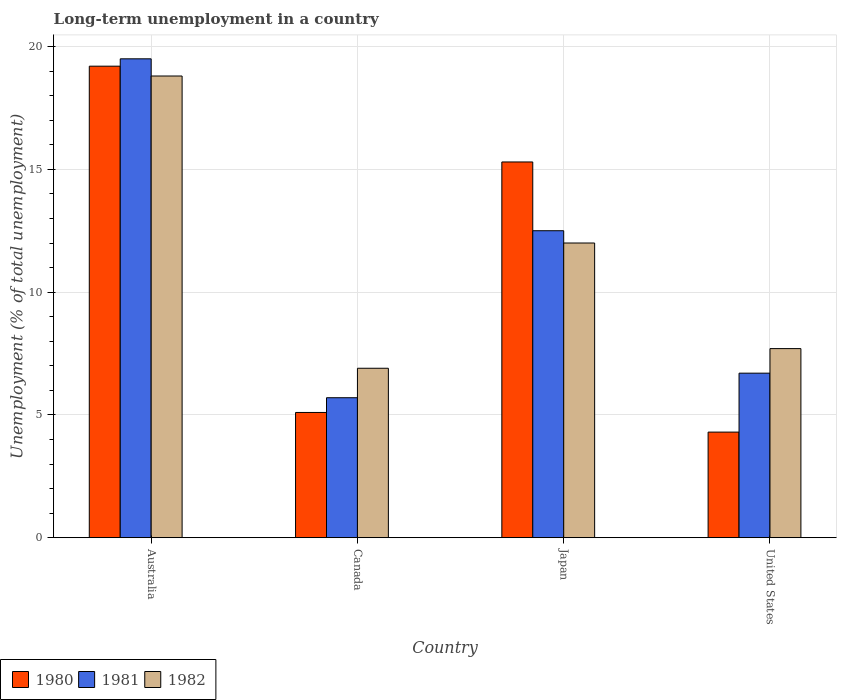How many different coloured bars are there?
Make the answer very short. 3. Are the number of bars per tick equal to the number of legend labels?
Provide a short and direct response. Yes. Are the number of bars on each tick of the X-axis equal?
Your answer should be very brief. Yes. How many bars are there on the 1st tick from the left?
Make the answer very short. 3. What is the percentage of long-term unemployed population in 1982 in United States?
Your response must be concise. 7.7. Across all countries, what is the maximum percentage of long-term unemployed population in 1982?
Your response must be concise. 18.8. Across all countries, what is the minimum percentage of long-term unemployed population in 1982?
Provide a short and direct response. 6.9. In which country was the percentage of long-term unemployed population in 1980 maximum?
Offer a terse response. Australia. What is the total percentage of long-term unemployed population in 1981 in the graph?
Provide a short and direct response. 44.4. What is the difference between the percentage of long-term unemployed population in 1981 in Australia and that in United States?
Ensure brevity in your answer.  12.8. What is the difference between the percentage of long-term unemployed population in 1980 in United States and the percentage of long-term unemployed population in 1981 in Japan?
Ensure brevity in your answer.  -8.2. What is the average percentage of long-term unemployed population in 1981 per country?
Give a very brief answer. 11.1. What is the difference between the percentage of long-term unemployed population of/in 1980 and percentage of long-term unemployed population of/in 1982 in Japan?
Offer a terse response. 3.3. In how many countries, is the percentage of long-term unemployed population in 1982 greater than 4 %?
Your answer should be compact. 4. What is the ratio of the percentage of long-term unemployed population in 1982 in Canada to that in Japan?
Provide a succinct answer. 0.58. Is the difference between the percentage of long-term unemployed population in 1980 in Australia and Canada greater than the difference between the percentage of long-term unemployed population in 1982 in Australia and Canada?
Offer a very short reply. Yes. What is the difference between the highest and the second highest percentage of long-term unemployed population in 1980?
Offer a very short reply. 14.1. What is the difference between the highest and the lowest percentage of long-term unemployed population in 1981?
Your response must be concise. 13.8. In how many countries, is the percentage of long-term unemployed population in 1980 greater than the average percentage of long-term unemployed population in 1980 taken over all countries?
Ensure brevity in your answer.  2. What does the 1st bar from the left in Japan represents?
Make the answer very short. 1980. Are all the bars in the graph horizontal?
Make the answer very short. No. How many legend labels are there?
Give a very brief answer. 3. How are the legend labels stacked?
Your response must be concise. Horizontal. What is the title of the graph?
Make the answer very short. Long-term unemployment in a country. What is the label or title of the Y-axis?
Your answer should be compact. Unemployment (% of total unemployment). What is the Unemployment (% of total unemployment) of 1980 in Australia?
Offer a terse response. 19.2. What is the Unemployment (% of total unemployment) of 1981 in Australia?
Make the answer very short. 19.5. What is the Unemployment (% of total unemployment) in 1982 in Australia?
Ensure brevity in your answer.  18.8. What is the Unemployment (% of total unemployment) of 1980 in Canada?
Your answer should be very brief. 5.1. What is the Unemployment (% of total unemployment) of 1981 in Canada?
Offer a terse response. 5.7. What is the Unemployment (% of total unemployment) of 1982 in Canada?
Ensure brevity in your answer.  6.9. What is the Unemployment (% of total unemployment) in 1980 in Japan?
Offer a very short reply. 15.3. What is the Unemployment (% of total unemployment) in 1981 in Japan?
Your answer should be very brief. 12.5. What is the Unemployment (% of total unemployment) of 1982 in Japan?
Offer a terse response. 12. What is the Unemployment (% of total unemployment) in 1980 in United States?
Provide a short and direct response. 4.3. What is the Unemployment (% of total unemployment) of 1981 in United States?
Your response must be concise. 6.7. What is the Unemployment (% of total unemployment) in 1982 in United States?
Make the answer very short. 7.7. Across all countries, what is the maximum Unemployment (% of total unemployment) in 1980?
Make the answer very short. 19.2. Across all countries, what is the maximum Unemployment (% of total unemployment) in 1982?
Make the answer very short. 18.8. Across all countries, what is the minimum Unemployment (% of total unemployment) in 1980?
Offer a very short reply. 4.3. Across all countries, what is the minimum Unemployment (% of total unemployment) in 1981?
Offer a terse response. 5.7. Across all countries, what is the minimum Unemployment (% of total unemployment) in 1982?
Your response must be concise. 6.9. What is the total Unemployment (% of total unemployment) of 1980 in the graph?
Offer a very short reply. 43.9. What is the total Unemployment (% of total unemployment) of 1981 in the graph?
Provide a short and direct response. 44.4. What is the total Unemployment (% of total unemployment) in 1982 in the graph?
Your answer should be compact. 45.4. What is the difference between the Unemployment (% of total unemployment) of 1982 in Australia and that in Canada?
Give a very brief answer. 11.9. What is the difference between the Unemployment (% of total unemployment) of 1982 in Australia and that in Japan?
Your response must be concise. 6.8. What is the difference between the Unemployment (% of total unemployment) of 1980 in Australia and that in United States?
Offer a terse response. 14.9. What is the difference between the Unemployment (% of total unemployment) of 1981 in Australia and that in United States?
Offer a very short reply. 12.8. What is the difference between the Unemployment (% of total unemployment) in 1982 in Australia and that in United States?
Provide a succinct answer. 11.1. What is the difference between the Unemployment (% of total unemployment) of 1981 in Canada and that in Japan?
Provide a short and direct response. -6.8. What is the difference between the Unemployment (% of total unemployment) in 1982 in Canada and that in Japan?
Give a very brief answer. -5.1. What is the difference between the Unemployment (% of total unemployment) in 1980 in Canada and that in United States?
Offer a terse response. 0.8. What is the difference between the Unemployment (% of total unemployment) in 1981 in Canada and that in United States?
Make the answer very short. -1. What is the difference between the Unemployment (% of total unemployment) of 1981 in Japan and that in United States?
Ensure brevity in your answer.  5.8. What is the difference between the Unemployment (% of total unemployment) in 1982 in Japan and that in United States?
Make the answer very short. 4.3. What is the difference between the Unemployment (% of total unemployment) in 1980 in Australia and the Unemployment (% of total unemployment) in 1982 in Canada?
Give a very brief answer. 12.3. What is the difference between the Unemployment (% of total unemployment) in 1980 in Australia and the Unemployment (% of total unemployment) in 1981 in Japan?
Offer a very short reply. 6.7. What is the difference between the Unemployment (% of total unemployment) in 1980 in Australia and the Unemployment (% of total unemployment) in 1981 in United States?
Keep it short and to the point. 12.5. What is the difference between the Unemployment (% of total unemployment) in 1980 in Australia and the Unemployment (% of total unemployment) in 1982 in United States?
Offer a terse response. 11.5. What is the difference between the Unemployment (% of total unemployment) in 1981 in Australia and the Unemployment (% of total unemployment) in 1982 in United States?
Give a very brief answer. 11.8. What is the difference between the Unemployment (% of total unemployment) of 1980 in Canada and the Unemployment (% of total unemployment) of 1982 in Japan?
Provide a short and direct response. -6.9. What is the difference between the Unemployment (% of total unemployment) of 1981 in Canada and the Unemployment (% of total unemployment) of 1982 in Japan?
Offer a terse response. -6.3. What is the difference between the Unemployment (% of total unemployment) of 1981 in Canada and the Unemployment (% of total unemployment) of 1982 in United States?
Your answer should be compact. -2. What is the difference between the Unemployment (% of total unemployment) in 1980 in Japan and the Unemployment (% of total unemployment) in 1982 in United States?
Give a very brief answer. 7.6. What is the difference between the Unemployment (% of total unemployment) of 1981 in Japan and the Unemployment (% of total unemployment) of 1982 in United States?
Provide a succinct answer. 4.8. What is the average Unemployment (% of total unemployment) in 1980 per country?
Make the answer very short. 10.97. What is the average Unemployment (% of total unemployment) of 1982 per country?
Make the answer very short. 11.35. What is the difference between the Unemployment (% of total unemployment) in 1980 and Unemployment (% of total unemployment) in 1982 in Australia?
Your answer should be compact. 0.4. What is the difference between the Unemployment (% of total unemployment) of 1981 and Unemployment (% of total unemployment) of 1982 in Australia?
Your response must be concise. 0.7. What is the difference between the Unemployment (% of total unemployment) of 1981 and Unemployment (% of total unemployment) of 1982 in Canada?
Ensure brevity in your answer.  -1.2. What is the difference between the Unemployment (% of total unemployment) of 1980 and Unemployment (% of total unemployment) of 1981 in Japan?
Your answer should be very brief. 2.8. What is the difference between the Unemployment (% of total unemployment) in 1981 and Unemployment (% of total unemployment) in 1982 in Japan?
Offer a very short reply. 0.5. What is the difference between the Unemployment (% of total unemployment) of 1980 and Unemployment (% of total unemployment) of 1981 in United States?
Make the answer very short. -2.4. What is the ratio of the Unemployment (% of total unemployment) in 1980 in Australia to that in Canada?
Your response must be concise. 3.76. What is the ratio of the Unemployment (% of total unemployment) of 1981 in Australia to that in Canada?
Ensure brevity in your answer.  3.42. What is the ratio of the Unemployment (% of total unemployment) in 1982 in Australia to that in Canada?
Your response must be concise. 2.72. What is the ratio of the Unemployment (% of total unemployment) of 1980 in Australia to that in Japan?
Ensure brevity in your answer.  1.25. What is the ratio of the Unemployment (% of total unemployment) in 1981 in Australia to that in Japan?
Your response must be concise. 1.56. What is the ratio of the Unemployment (% of total unemployment) of 1982 in Australia to that in Japan?
Your answer should be compact. 1.57. What is the ratio of the Unemployment (% of total unemployment) of 1980 in Australia to that in United States?
Provide a short and direct response. 4.47. What is the ratio of the Unemployment (% of total unemployment) of 1981 in Australia to that in United States?
Provide a succinct answer. 2.91. What is the ratio of the Unemployment (% of total unemployment) of 1982 in Australia to that in United States?
Your answer should be very brief. 2.44. What is the ratio of the Unemployment (% of total unemployment) in 1981 in Canada to that in Japan?
Your response must be concise. 0.46. What is the ratio of the Unemployment (% of total unemployment) in 1982 in Canada to that in Japan?
Keep it short and to the point. 0.57. What is the ratio of the Unemployment (% of total unemployment) in 1980 in Canada to that in United States?
Offer a very short reply. 1.19. What is the ratio of the Unemployment (% of total unemployment) of 1981 in Canada to that in United States?
Ensure brevity in your answer.  0.85. What is the ratio of the Unemployment (% of total unemployment) of 1982 in Canada to that in United States?
Offer a terse response. 0.9. What is the ratio of the Unemployment (% of total unemployment) in 1980 in Japan to that in United States?
Give a very brief answer. 3.56. What is the ratio of the Unemployment (% of total unemployment) of 1981 in Japan to that in United States?
Provide a short and direct response. 1.87. What is the ratio of the Unemployment (% of total unemployment) of 1982 in Japan to that in United States?
Offer a very short reply. 1.56. What is the difference between the highest and the second highest Unemployment (% of total unemployment) in 1980?
Offer a terse response. 3.9. What is the difference between the highest and the second highest Unemployment (% of total unemployment) in 1981?
Your answer should be compact. 7. What is the difference between the highest and the second highest Unemployment (% of total unemployment) of 1982?
Keep it short and to the point. 6.8. What is the difference between the highest and the lowest Unemployment (% of total unemployment) in 1980?
Offer a terse response. 14.9. What is the difference between the highest and the lowest Unemployment (% of total unemployment) in 1982?
Offer a terse response. 11.9. 